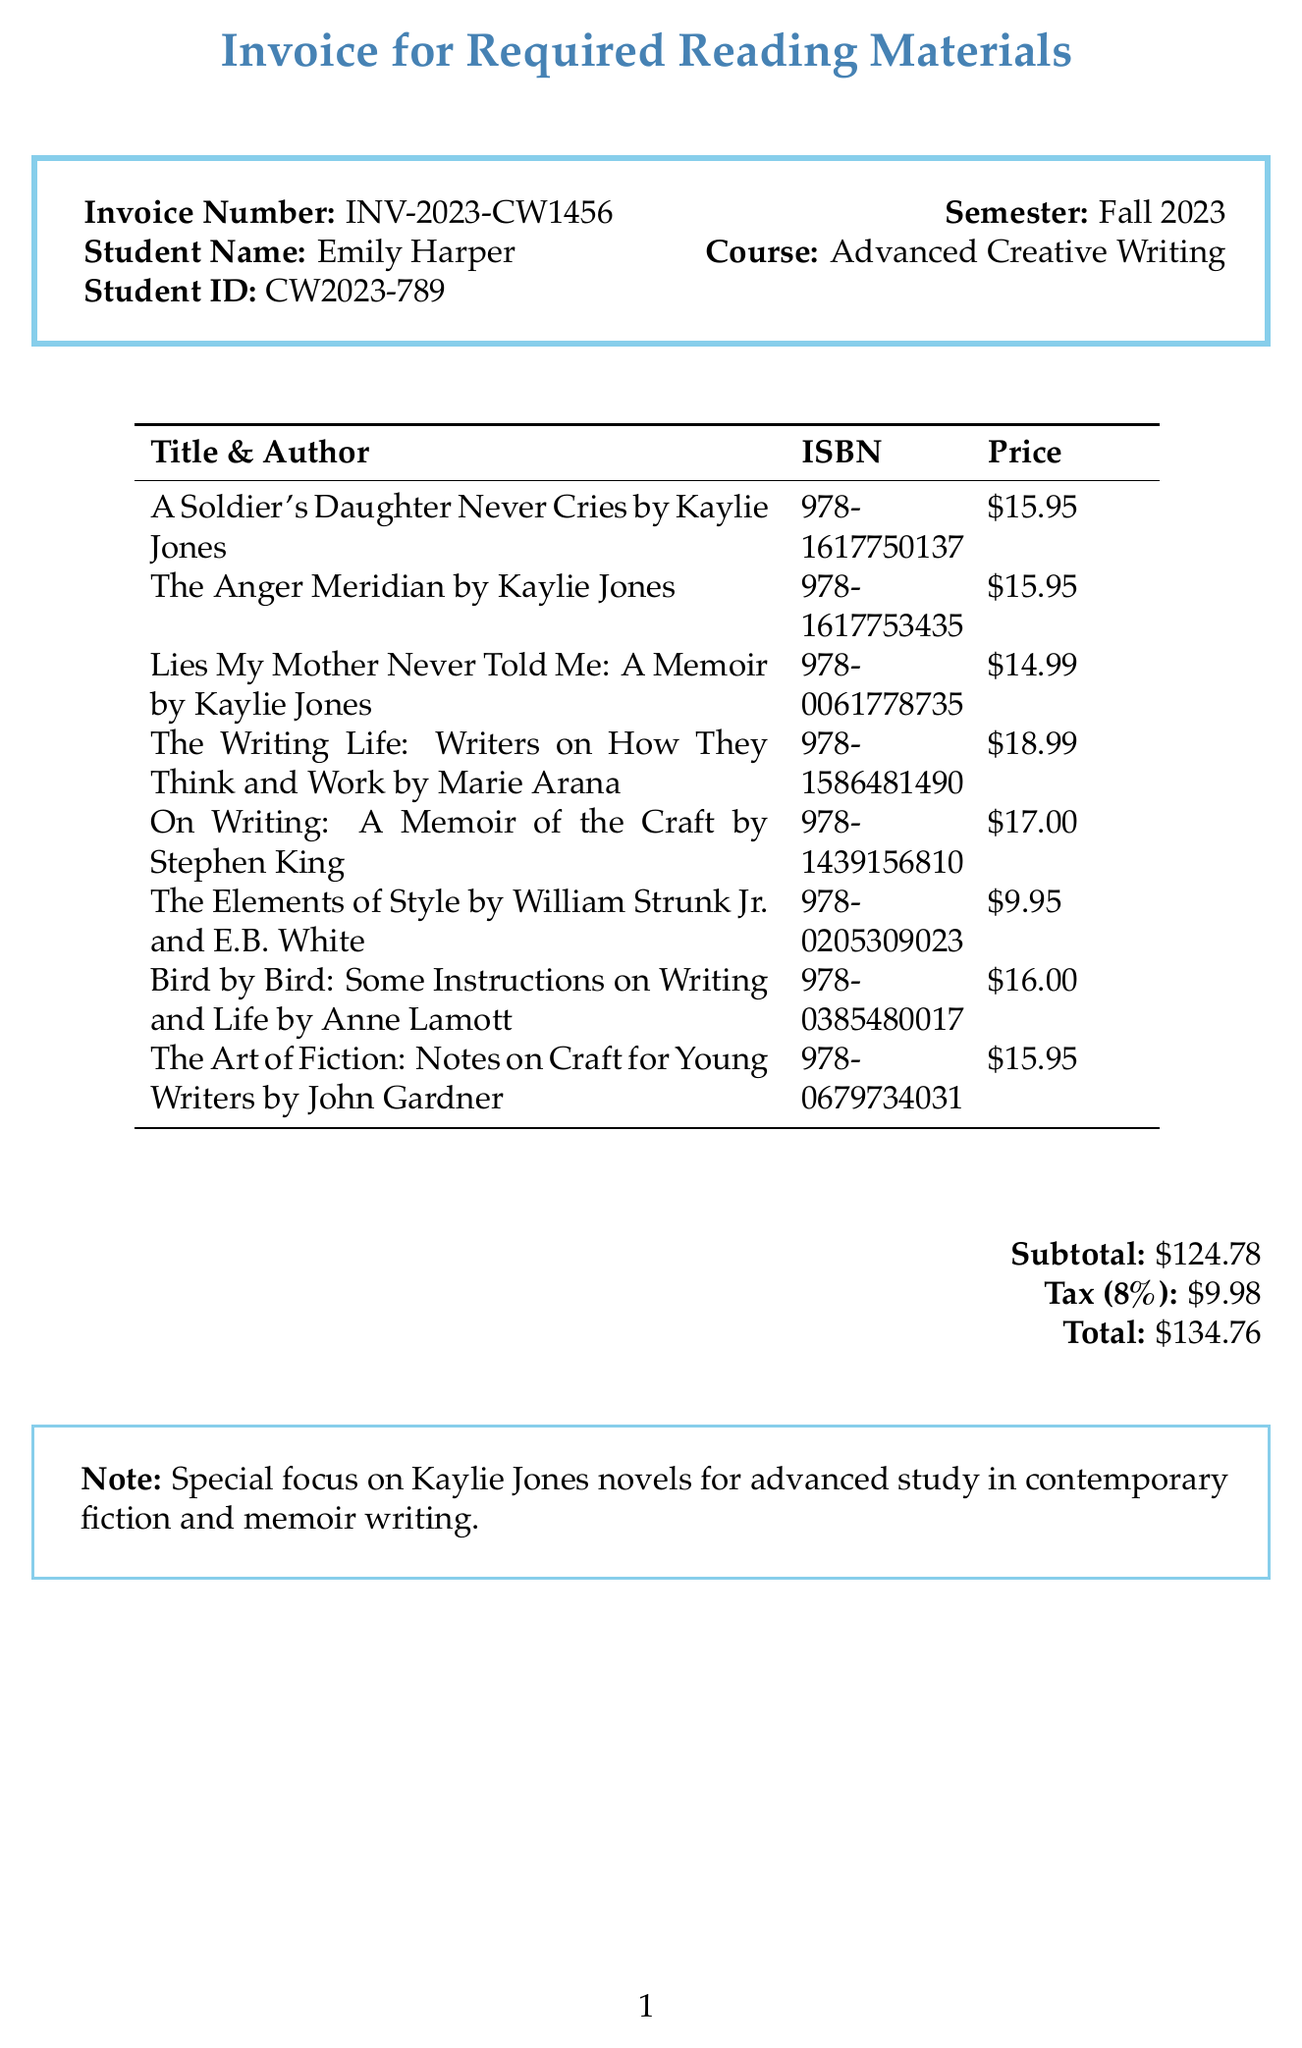What is the invoice number? The invoice number is a unique identifier for the invoice and is found at the top of the document.
Answer: INV-2023-CW1456 Who is the student? The student’s name is listed prominently on the invoice, identifying who the invoice is issued to.
Answer: Emily Harper What is the total amount due? The total amount due is the final sum to be paid, calculated from the subtotal and tax applied.
Answer: $134.76 How many Kaylie Jones novels are listed? The document lists specific novels by Kaylie Jones, and counting those provides the total.
Answer: 3 What is the tax rate applied? The tax rate is stated in the document, indicating how much tax is added to the subtotal.
Answer: 8% What is the semester for the course? The semester in which the reading materials are required is specified in the invoice details.
Answer: Fall 2023 Which publisher released "Lies My Mother Never Told Me: A Memoir"? The publisher information for each item is included, indicating where the book was published.
Answer: William Morrow Paperbacks What focus does the note emphasize? The note at the bottom of the document provides insights into the purpose of the reading materials.
Answer: Special focus on Kaylie Jones novels 